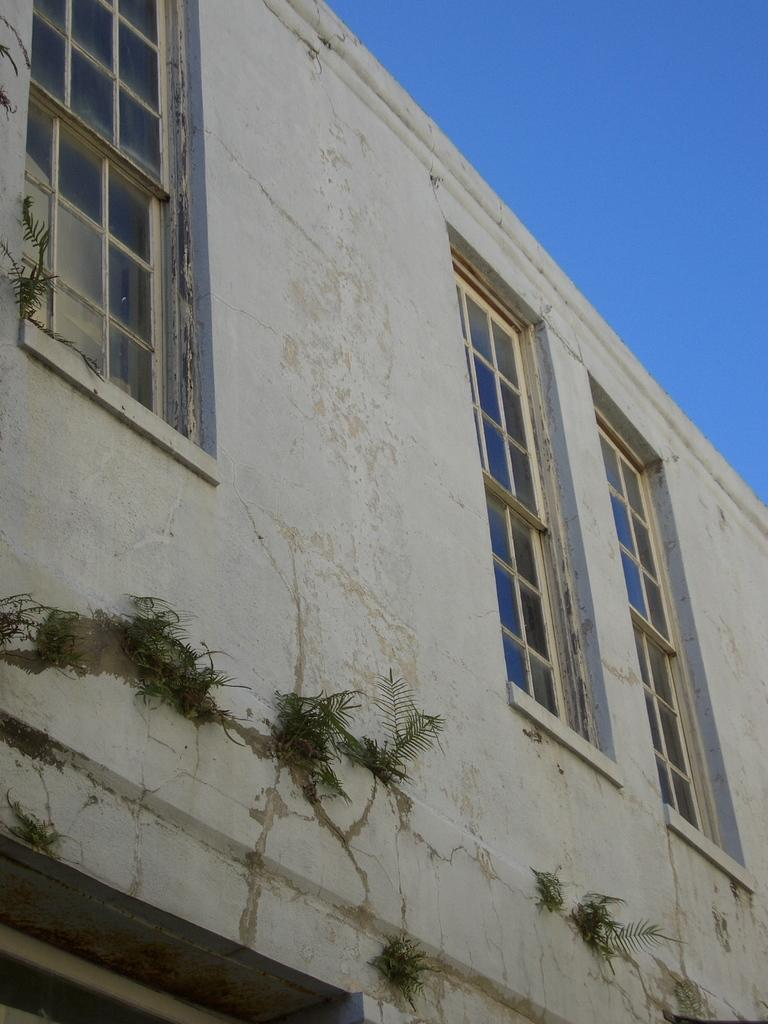What is the main structure in the image? There is a building in the image. What features can be observed on the building? The building has windows and plants on it. What can be seen in the background of the image? The sky is visible in the background of the image. How many times is the twig kicked in the image? There is no twig present in the image, so it cannot be kicked. 